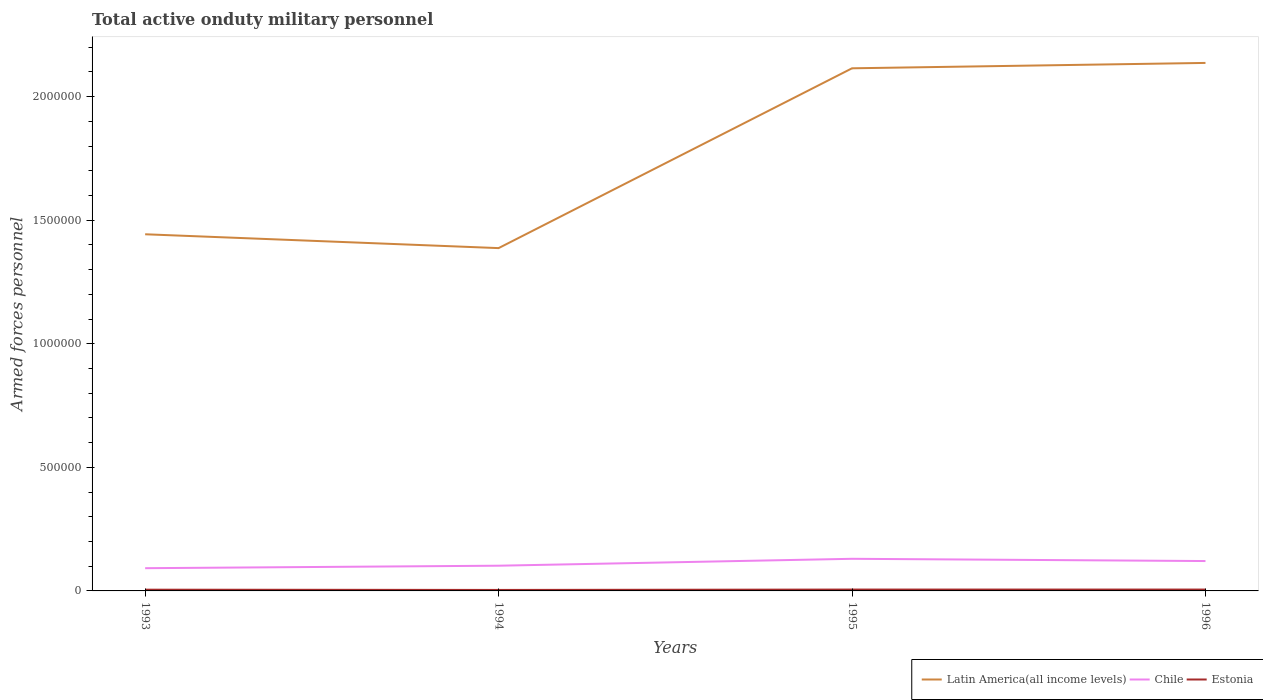How many different coloured lines are there?
Make the answer very short. 3. Is the number of lines equal to the number of legend labels?
Give a very brief answer. Yes. Across all years, what is the maximum number of armed forces personnel in Estonia?
Give a very brief answer. 4000. What is the total number of armed forces personnel in Latin America(all income levels) in the graph?
Give a very brief answer. -6.72e+05. What is the difference between the highest and the second highest number of armed forces personnel in Latin America(all income levels)?
Provide a short and direct response. 7.49e+05. What is the difference between the highest and the lowest number of armed forces personnel in Chile?
Your answer should be compact. 2. Is the number of armed forces personnel in Estonia strictly greater than the number of armed forces personnel in Latin America(all income levels) over the years?
Give a very brief answer. Yes. Are the values on the major ticks of Y-axis written in scientific E-notation?
Ensure brevity in your answer.  No. Does the graph contain grids?
Ensure brevity in your answer.  No. Where does the legend appear in the graph?
Give a very brief answer. Bottom right. How are the legend labels stacked?
Offer a terse response. Horizontal. What is the title of the graph?
Provide a short and direct response. Total active onduty military personnel. What is the label or title of the X-axis?
Offer a terse response. Years. What is the label or title of the Y-axis?
Ensure brevity in your answer.  Armed forces personnel. What is the Armed forces personnel of Latin America(all income levels) in 1993?
Offer a terse response. 1.44e+06. What is the Armed forces personnel in Chile in 1993?
Your answer should be compact. 9.20e+04. What is the Armed forces personnel in Estonia in 1993?
Your answer should be very brief. 5000. What is the Armed forces personnel of Latin America(all income levels) in 1994?
Provide a short and direct response. 1.39e+06. What is the Armed forces personnel in Chile in 1994?
Your response must be concise. 1.02e+05. What is the Armed forces personnel of Estonia in 1994?
Ensure brevity in your answer.  4000. What is the Armed forces personnel of Latin America(all income levels) in 1995?
Your answer should be compact. 2.11e+06. What is the Armed forces personnel in Estonia in 1995?
Offer a very short reply. 5500. What is the Armed forces personnel of Latin America(all income levels) in 1996?
Ensure brevity in your answer.  2.14e+06. What is the Armed forces personnel of Chile in 1996?
Make the answer very short. 1.21e+05. What is the Armed forces personnel in Estonia in 1996?
Keep it short and to the point. 5500. Across all years, what is the maximum Armed forces personnel of Latin America(all income levels)?
Your answer should be compact. 2.14e+06. Across all years, what is the maximum Armed forces personnel in Estonia?
Keep it short and to the point. 5500. Across all years, what is the minimum Armed forces personnel of Latin America(all income levels)?
Provide a succinct answer. 1.39e+06. Across all years, what is the minimum Armed forces personnel in Chile?
Offer a very short reply. 9.20e+04. Across all years, what is the minimum Armed forces personnel of Estonia?
Offer a terse response. 4000. What is the total Armed forces personnel in Latin America(all income levels) in the graph?
Provide a succinct answer. 7.08e+06. What is the total Armed forces personnel in Chile in the graph?
Offer a terse response. 4.45e+05. What is the total Armed forces personnel of Estonia in the graph?
Offer a terse response. 2.00e+04. What is the difference between the Armed forces personnel of Latin America(all income levels) in 1993 and that in 1994?
Ensure brevity in your answer.  5.60e+04. What is the difference between the Armed forces personnel of Estonia in 1993 and that in 1994?
Your answer should be compact. 1000. What is the difference between the Armed forces personnel in Latin America(all income levels) in 1993 and that in 1995?
Offer a very short reply. -6.72e+05. What is the difference between the Armed forces personnel of Chile in 1993 and that in 1995?
Make the answer very short. -3.80e+04. What is the difference between the Armed forces personnel in Estonia in 1993 and that in 1995?
Provide a succinct answer. -500. What is the difference between the Armed forces personnel in Latin America(all income levels) in 1993 and that in 1996?
Offer a terse response. -6.93e+05. What is the difference between the Armed forces personnel in Chile in 1993 and that in 1996?
Keep it short and to the point. -2.89e+04. What is the difference between the Armed forces personnel of Estonia in 1993 and that in 1996?
Your answer should be compact. -500. What is the difference between the Armed forces personnel of Latin America(all income levels) in 1994 and that in 1995?
Provide a succinct answer. -7.28e+05. What is the difference between the Armed forces personnel in Chile in 1994 and that in 1995?
Keep it short and to the point. -2.80e+04. What is the difference between the Armed forces personnel of Estonia in 1994 and that in 1995?
Offer a very short reply. -1500. What is the difference between the Armed forces personnel in Latin America(all income levels) in 1994 and that in 1996?
Your response must be concise. -7.49e+05. What is the difference between the Armed forces personnel in Chile in 1994 and that in 1996?
Ensure brevity in your answer.  -1.89e+04. What is the difference between the Armed forces personnel in Estonia in 1994 and that in 1996?
Keep it short and to the point. -1500. What is the difference between the Armed forces personnel of Latin America(all income levels) in 1995 and that in 1996?
Offer a terse response. -2.17e+04. What is the difference between the Armed forces personnel of Chile in 1995 and that in 1996?
Provide a short and direct response. 9100. What is the difference between the Armed forces personnel in Latin America(all income levels) in 1993 and the Armed forces personnel in Chile in 1994?
Offer a very short reply. 1.34e+06. What is the difference between the Armed forces personnel of Latin America(all income levels) in 1993 and the Armed forces personnel of Estonia in 1994?
Provide a short and direct response. 1.44e+06. What is the difference between the Armed forces personnel in Chile in 1993 and the Armed forces personnel in Estonia in 1994?
Your answer should be very brief. 8.80e+04. What is the difference between the Armed forces personnel in Latin America(all income levels) in 1993 and the Armed forces personnel in Chile in 1995?
Offer a very short reply. 1.31e+06. What is the difference between the Armed forces personnel in Latin America(all income levels) in 1993 and the Armed forces personnel in Estonia in 1995?
Your answer should be compact. 1.44e+06. What is the difference between the Armed forces personnel of Chile in 1993 and the Armed forces personnel of Estonia in 1995?
Your answer should be very brief. 8.65e+04. What is the difference between the Armed forces personnel in Latin America(all income levels) in 1993 and the Armed forces personnel in Chile in 1996?
Your answer should be very brief. 1.32e+06. What is the difference between the Armed forces personnel in Latin America(all income levels) in 1993 and the Armed forces personnel in Estonia in 1996?
Offer a very short reply. 1.44e+06. What is the difference between the Armed forces personnel of Chile in 1993 and the Armed forces personnel of Estonia in 1996?
Keep it short and to the point. 8.65e+04. What is the difference between the Armed forces personnel of Latin America(all income levels) in 1994 and the Armed forces personnel of Chile in 1995?
Make the answer very short. 1.26e+06. What is the difference between the Armed forces personnel in Latin America(all income levels) in 1994 and the Armed forces personnel in Estonia in 1995?
Keep it short and to the point. 1.38e+06. What is the difference between the Armed forces personnel in Chile in 1994 and the Armed forces personnel in Estonia in 1995?
Make the answer very short. 9.65e+04. What is the difference between the Armed forces personnel in Latin America(all income levels) in 1994 and the Armed forces personnel in Chile in 1996?
Give a very brief answer. 1.27e+06. What is the difference between the Armed forces personnel of Latin America(all income levels) in 1994 and the Armed forces personnel of Estonia in 1996?
Keep it short and to the point. 1.38e+06. What is the difference between the Armed forces personnel in Chile in 1994 and the Armed forces personnel in Estonia in 1996?
Keep it short and to the point. 9.65e+04. What is the difference between the Armed forces personnel in Latin America(all income levels) in 1995 and the Armed forces personnel in Chile in 1996?
Make the answer very short. 1.99e+06. What is the difference between the Armed forces personnel of Latin America(all income levels) in 1995 and the Armed forces personnel of Estonia in 1996?
Your response must be concise. 2.11e+06. What is the difference between the Armed forces personnel in Chile in 1995 and the Armed forces personnel in Estonia in 1996?
Provide a succinct answer. 1.24e+05. What is the average Armed forces personnel in Latin America(all income levels) per year?
Your answer should be very brief. 1.77e+06. What is the average Armed forces personnel in Chile per year?
Offer a terse response. 1.11e+05. What is the average Armed forces personnel of Estonia per year?
Ensure brevity in your answer.  5000. In the year 1993, what is the difference between the Armed forces personnel of Latin America(all income levels) and Armed forces personnel of Chile?
Keep it short and to the point. 1.35e+06. In the year 1993, what is the difference between the Armed forces personnel of Latin America(all income levels) and Armed forces personnel of Estonia?
Make the answer very short. 1.44e+06. In the year 1993, what is the difference between the Armed forces personnel in Chile and Armed forces personnel in Estonia?
Your answer should be very brief. 8.70e+04. In the year 1994, what is the difference between the Armed forces personnel in Latin America(all income levels) and Armed forces personnel in Chile?
Ensure brevity in your answer.  1.28e+06. In the year 1994, what is the difference between the Armed forces personnel in Latin America(all income levels) and Armed forces personnel in Estonia?
Give a very brief answer. 1.38e+06. In the year 1994, what is the difference between the Armed forces personnel of Chile and Armed forces personnel of Estonia?
Provide a succinct answer. 9.80e+04. In the year 1995, what is the difference between the Armed forces personnel of Latin America(all income levels) and Armed forces personnel of Chile?
Ensure brevity in your answer.  1.98e+06. In the year 1995, what is the difference between the Armed forces personnel in Latin America(all income levels) and Armed forces personnel in Estonia?
Provide a short and direct response. 2.11e+06. In the year 1995, what is the difference between the Armed forces personnel in Chile and Armed forces personnel in Estonia?
Your response must be concise. 1.24e+05. In the year 1996, what is the difference between the Armed forces personnel in Latin America(all income levels) and Armed forces personnel in Chile?
Your response must be concise. 2.02e+06. In the year 1996, what is the difference between the Armed forces personnel in Latin America(all income levels) and Armed forces personnel in Estonia?
Provide a succinct answer. 2.13e+06. In the year 1996, what is the difference between the Armed forces personnel in Chile and Armed forces personnel in Estonia?
Your response must be concise. 1.15e+05. What is the ratio of the Armed forces personnel in Latin America(all income levels) in 1993 to that in 1994?
Make the answer very short. 1.04. What is the ratio of the Armed forces personnel of Chile in 1993 to that in 1994?
Your response must be concise. 0.9. What is the ratio of the Armed forces personnel in Estonia in 1993 to that in 1994?
Keep it short and to the point. 1.25. What is the ratio of the Armed forces personnel in Latin America(all income levels) in 1993 to that in 1995?
Provide a short and direct response. 0.68. What is the ratio of the Armed forces personnel in Chile in 1993 to that in 1995?
Offer a very short reply. 0.71. What is the ratio of the Armed forces personnel of Latin America(all income levels) in 1993 to that in 1996?
Make the answer very short. 0.68. What is the ratio of the Armed forces personnel of Chile in 1993 to that in 1996?
Offer a very short reply. 0.76. What is the ratio of the Armed forces personnel in Estonia in 1993 to that in 1996?
Make the answer very short. 0.91. What is the ratio of the Armed forces personnel of Latin America(all income levels) in 1994 to that in 1995?
Provide a short and direct response. 0.66. What is the ratio of the Armed forces personnel of Chile in 1994 to that in 1995?
Offer a terse response. 0.78. What is the ratio of the Armed forces personnel of Estonia in 1994 to that in 1995?
Make the answer very short. 0.73. What is the ratio of the Armed forces personnel in Latin America(all income levels) in 1994 to that in 1996?
Provide a short and direct response. 0.65. What is the ratio of the Armed forces personnel in Chile in 1994 to that in 1996?
Provide a succinct answer. 0.84. What is the ratio of the Armed forces personnel in Estonia in 1994 to that in 1996?
Keep it short and to the point. 0.73. What is the ratio of the Armed forces personnel in Chile in 1995 to that in 1996?
Keep it short and to the point. 1.08. What is the ratio of the Armed forces personnel of Estonia in 1995 to that in 1996?
Your answer should be very brief. 1. What is the difference between the highest and the second highest Armed forces personnel of Latin America(all income levels)?
Offer a very short reply. 2.17e+04. What is the difference between the highest and the second highest Armed forces personnel of Chile?
Your response must be concise. 9100. What is the difference between the highest and the lowest Armed forces personnel in Latin America(all income levels)?
Provide a succinct answer. 7.49e+05. What is the difference between the highest and the lowest Armed forces personnel in Chile?
Your answer should be compact. 3.80e+04. What is the difference between the highest and the lowest Armed forces personnel of Estonia?
Provide a short and direct response. 1500. 